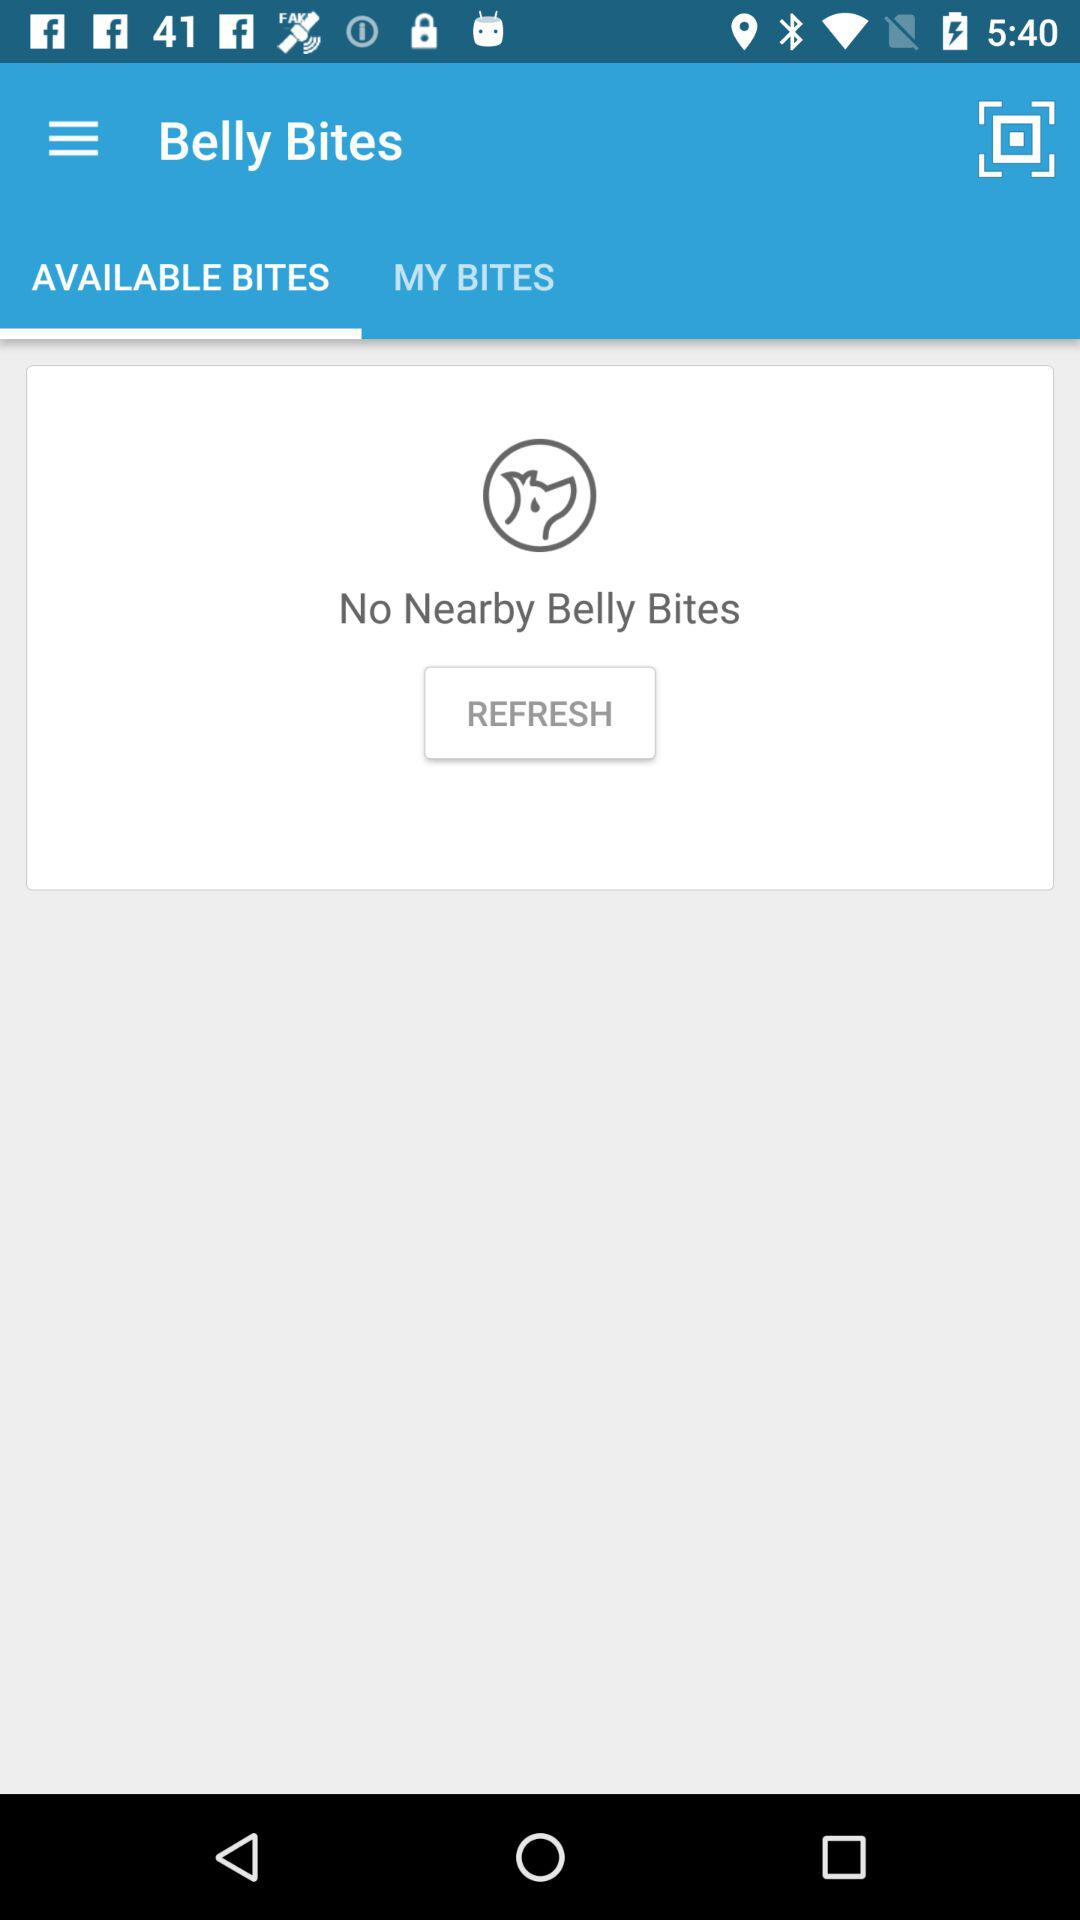Which option is selected for belly bites? The selected option is "AVAILABLE BITES". 